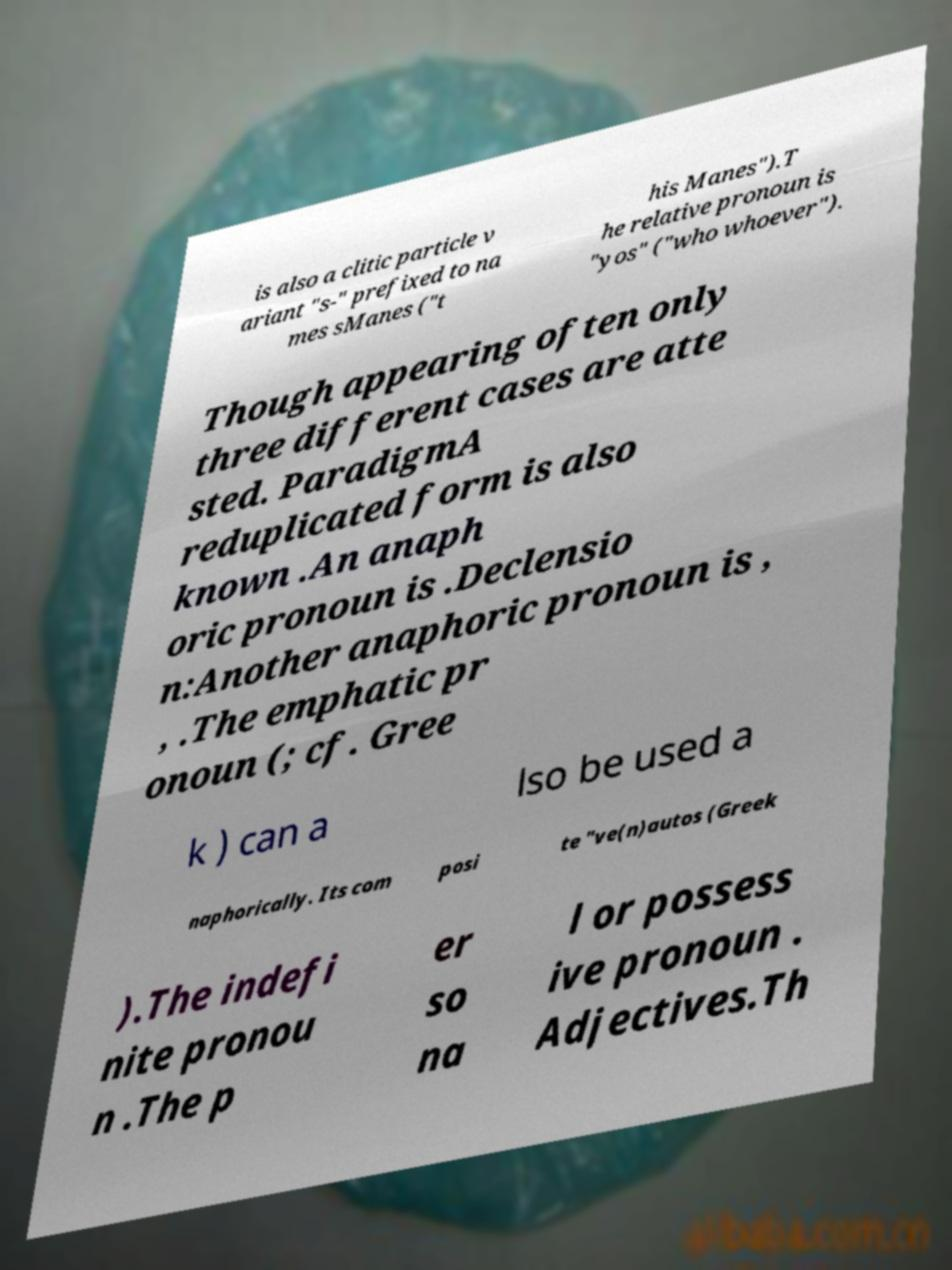What messages or text are displayed in this image? I need them in a readable, typed format. is also a clitic particle v ariant "s-" prefixed to na mes sManes ("t his Manes").T he relative pronoun is "yos" ("who whoever"). Though appearing often only three different cases are atte sted. ParadigmA reduplicated form is also known .An anaph oric pronoun is .Declensio n:Another anaphoric pronoun is , , .The emphatic pr onoun (; cf. Gree k ) can a lso be used a naphorically. Its com posi te "ve(n)autos (Greek ).The indefi nite pronou n .The p er so na l or possess ive pronoun . Adjectives.Th 